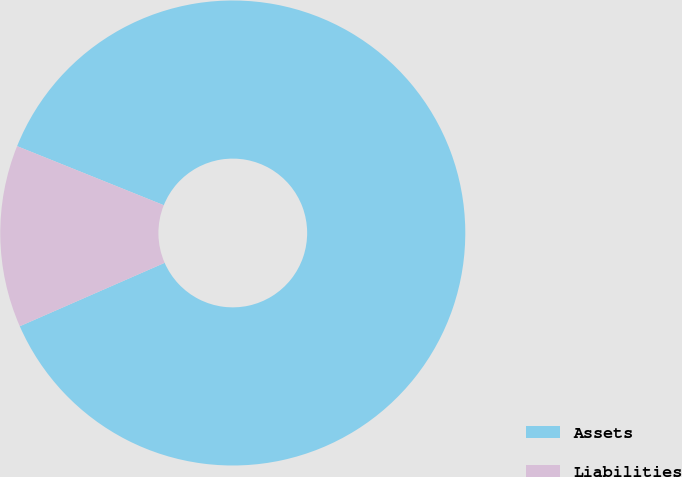<chart> <loc_0><loc_0><loc_500><loc_500><pie_chart><fcel>Assets<fcel>Liabilities<nl><fcel>87.34%<fcel>12.66%<nl></chart> 